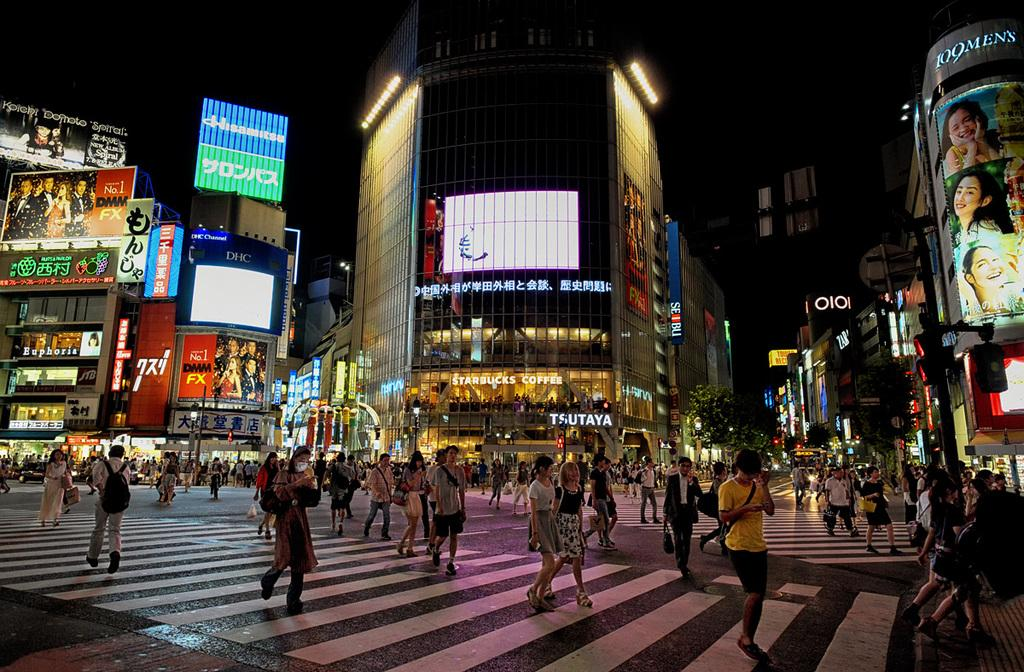What are the people in the image doing? The people in the image are walking on the road. What can be seen in the background of the image? There are buildings and the sky visible in the background of the image. What is the weight of the tent in the image? There is no tent present in the image, so it is not possible to determine its weight. 